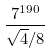<formula> <loc_0><loc_0><loc_500><loc_500>\frac { 7 ^ { 1 9 0 } } { \sqrt { 4 } / 8 }</formula> 